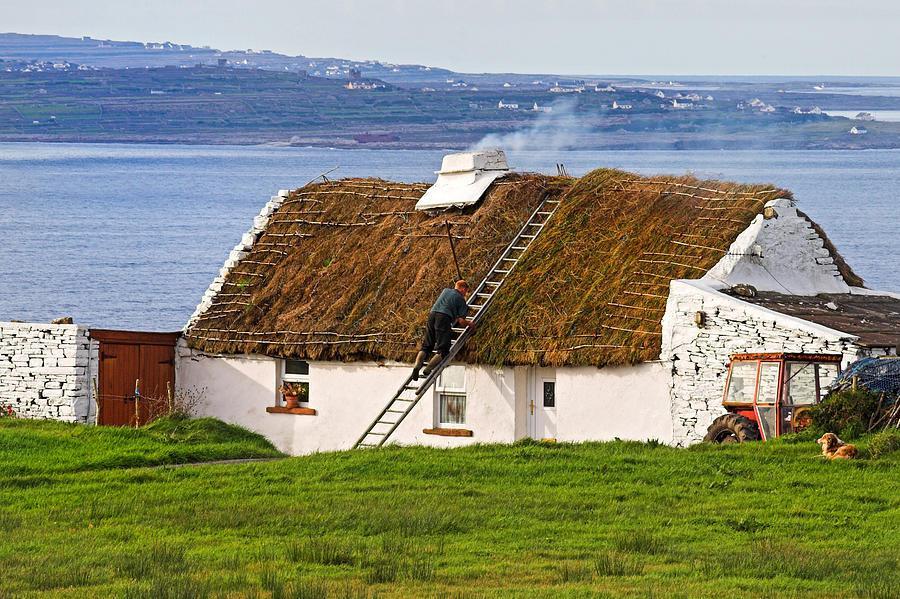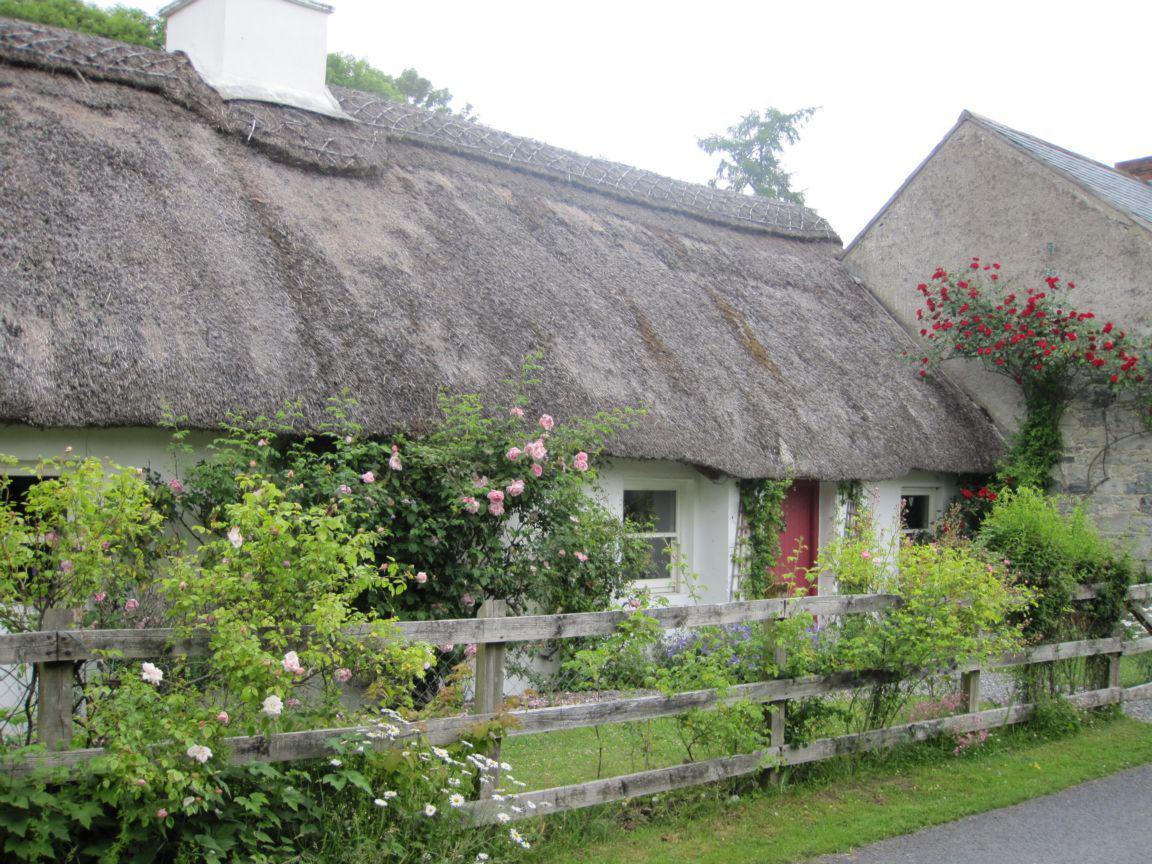The first image is the image on the left, the second image is the image on the right. For the images displayed, is the sentence "There are no fewer than 2 chimneys in the image on the left." factually correct? Answer yes or no. No. The first image is the image on the left, the second image is the image on the right. For the images shown, is this caption "The house in the left image has one chimney." true? Answer yes or no. Yes. 